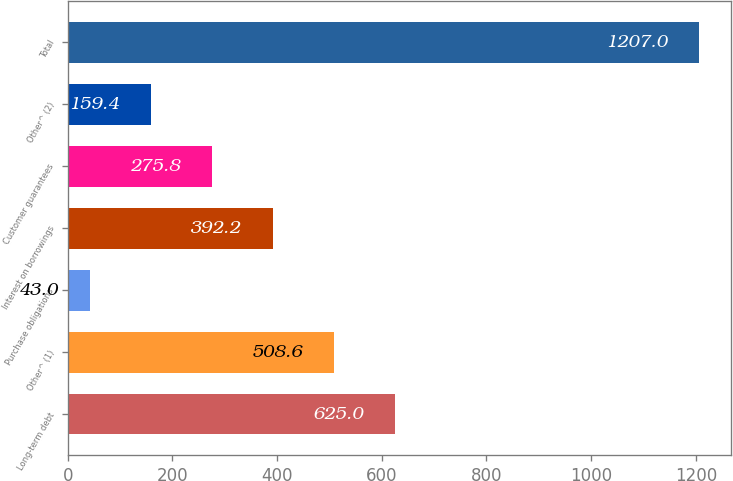Convert chart to OTSL. <chart><loc_0><loc_0><loc_500><loc_500><bar_chart><fcel>Long-term debt<fcel>Other^ (1)<fcel>Purchase obligations<fcel>Interest on borrowings<fcel>Customer guarantees<fcel>Other^ (2)<fcel>Total<nl><fcel>625<fcel>508.6<fcel>43<fcel>392.2<fcel>275.8<fcel>159.4<fcel>1207<nl></chart> 